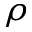Convert formula to latex. <formula><loc_0><loc_0><loc_500><loc_500>\rho</formula> 